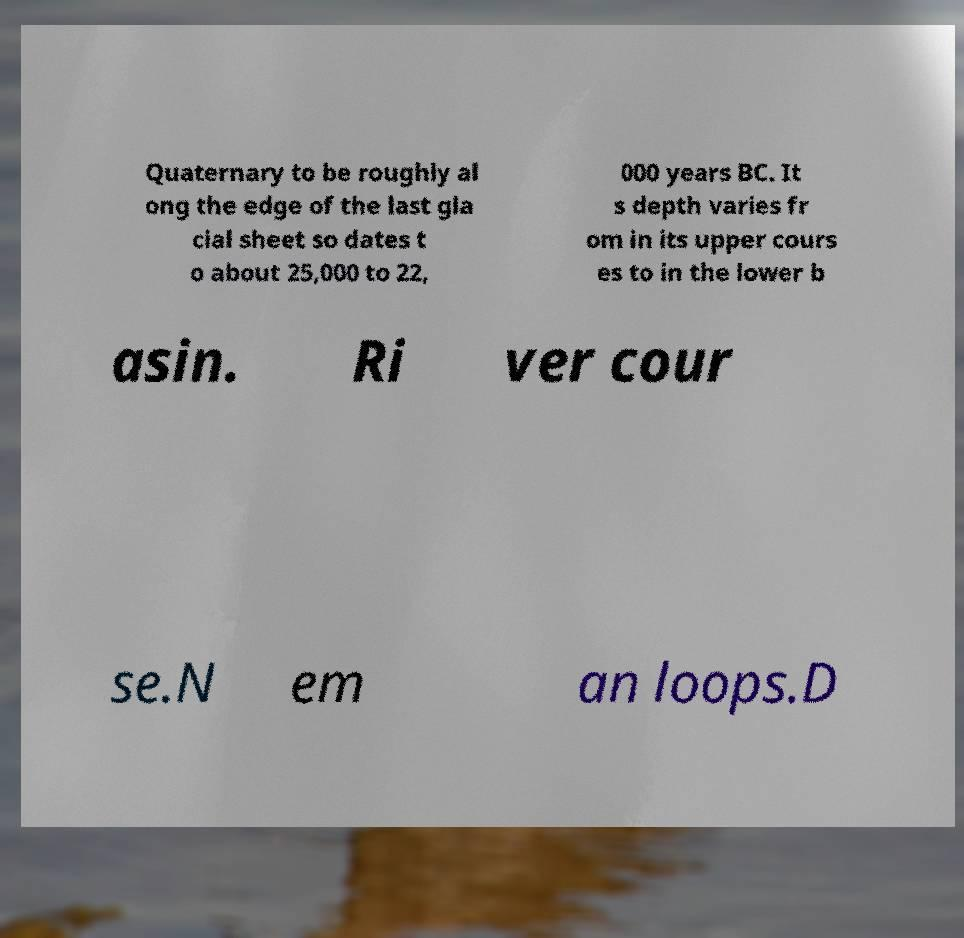For documentation purposes, I need the text within this image transcribed. Could you provide that? Quaternary to be roughly al ong the edge of the last gla cial sheet so dates t o about 25,000 to 22, 000 years BC. It s depth varies fr om in its upper cours es to in the lower b asin. Ri ver cour se.N em an loops.D 